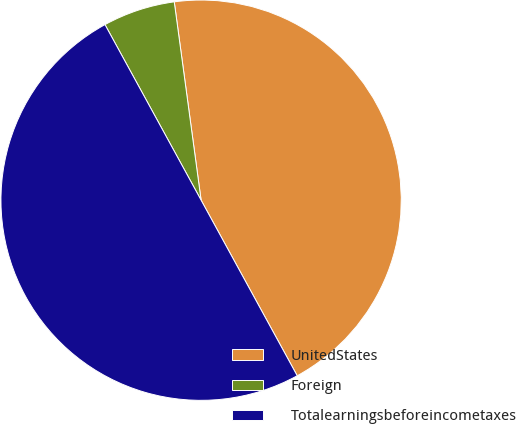Convert chart. <chart><loc_0><loc_0><loc_500><loc_500><pie_chart><fcel>UnitedStates<fcel>Foreign<fcel>Totalearningsbeforeincometaxes<nl><fcel>44.17%<fcel>5.83%<fcel>50.0%<nl></chart> 